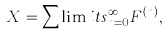Convert formula to latex. <formula><loc_0><loc_0><loc_500><loc_500>X = \sum \lim i t s _ { n = 0 } ^ { \infty } F ^ { ( n ) } ,</formula> 